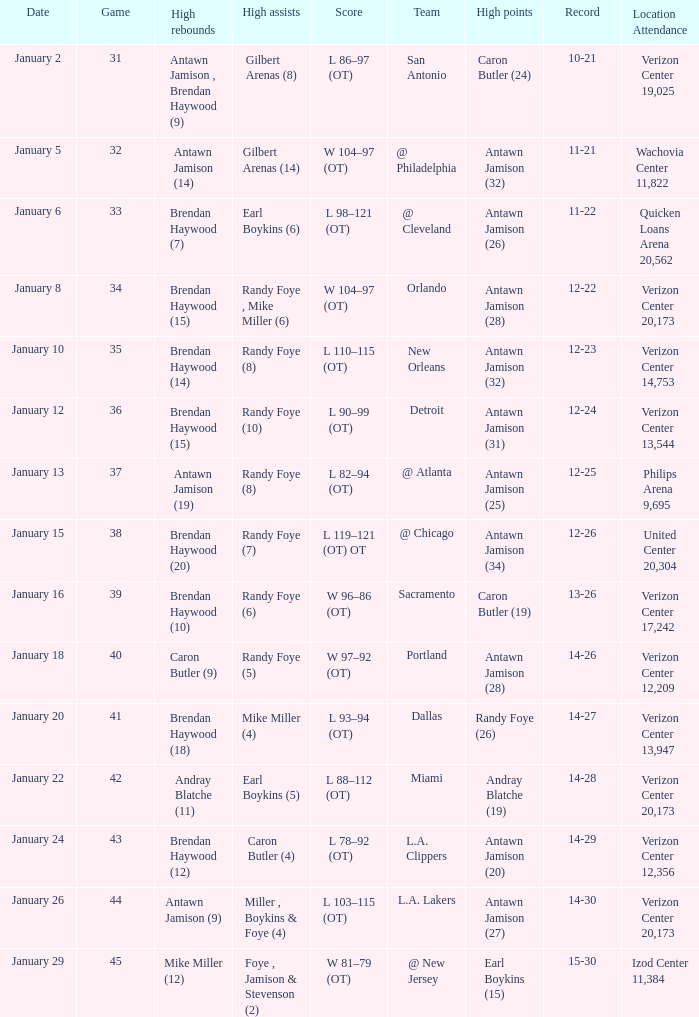How many people got high points in game 35? 1.0. 